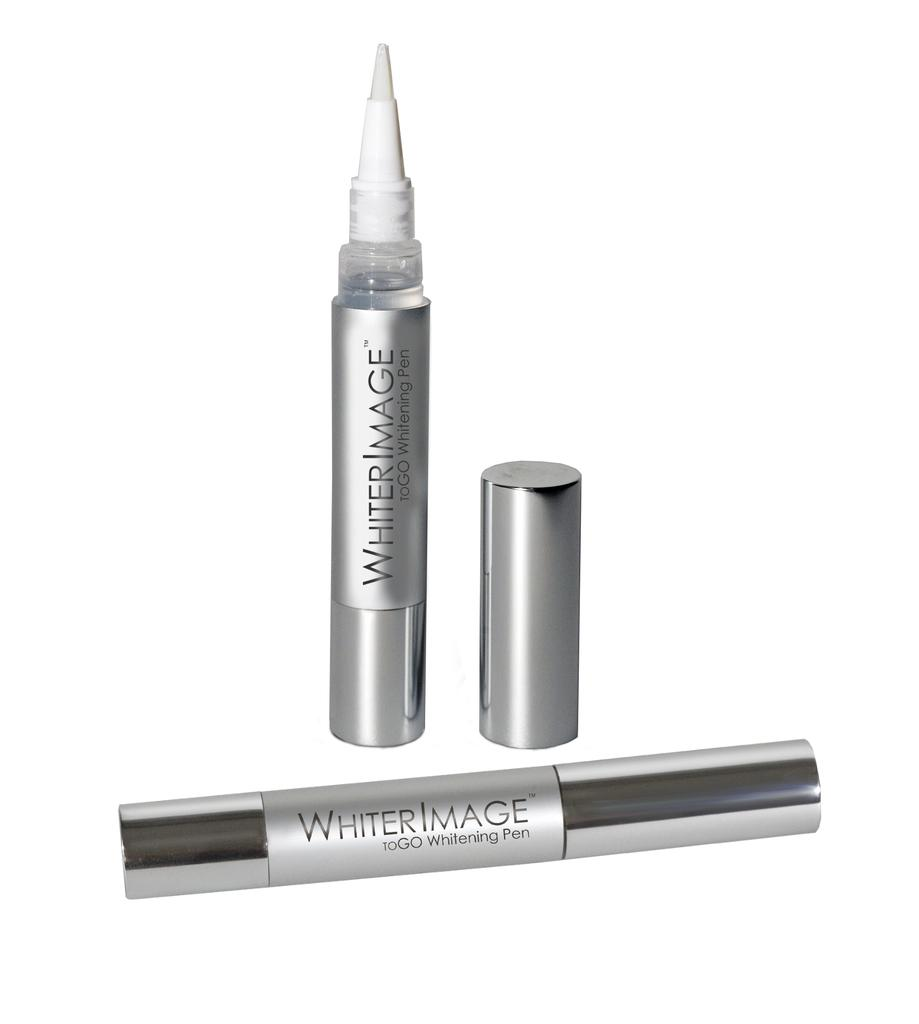What type of writing instrument is in the image? There is a whitener pen in the image. What is the status of the cap on the first pen? The cap of the whitener pen is removed. Where is the removed cap placed in the image? The removed cap is placed beside the pen. How many whitener pens are in the image? There are two whitener pens in the image. What is the status of the cap on the second pen? The cap of the second pen is fixed. What is written on the second pen? The second pen has the name "Whiter Image" on it. What type of quilt is being used to cover the seashore in the image? There is no quilt or seashore present in the image; it features two whitener pens and their respective caps. 